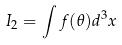<formula> <loc_0><loc_0><loc_500><loc_500>I _ { 2 } = \int f ( \theta ) d ^ { 3 } x</formula> 